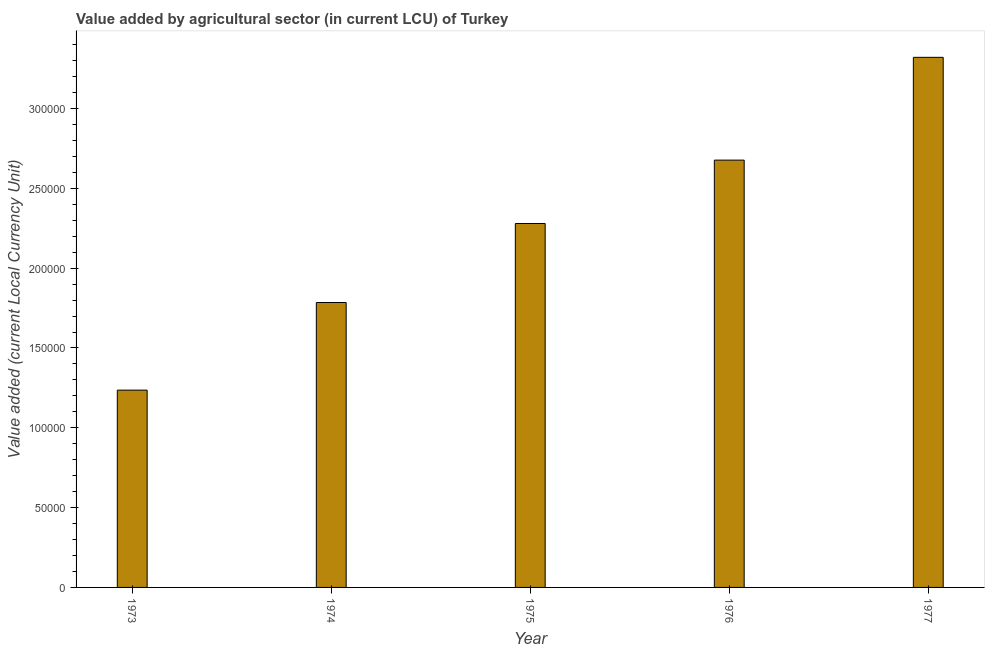Does the graph contain any zero values?
Your answer should be compact. No. What is the title of the graph?
Make the answer very short. Value added by agricultural sector (in current LCU) of Turkey. What is the label or title of the X-axis?
Your response must be concise. Year. What is the label or title of the Y-axis?
Your answer should be compact. Value added (current Local Currency Unit). What is the value added by agriculture sector in 1975?
Your answer should be compact. 2.28e+05. Across all years, what is the maximum value added by agriculture sector?
Ensure brevity in your answer.  3.32e+05. Across all years, what is the minimum value added by agriculture sector?
Make the answer very short. 1.24e+05. What is the sum of the value added by agriculture sector?
Give a very brief answer. 1.13e+06. What is the difference between the value added by agriculture sector in 1973 and 1976?
Provide a short and direct response. -1.44e+05. What is the average value added by agriculture sector per year?
Provide a short and direct response. 2.26e+05. What is the median value added by agriculture sector?
Offer a terse response. 2.28e+05. In how many years, is the value added by agriculture sector greater than 300000 LCU?
Provide a short and direct response. 1. Do a majority of the years between 1977 and 1973 (inclusive) have value added by agriculture sector greater than 150000 LCU?
Give a very brief answer. Yes. What is the ratio of the value added by agriculture sector in 1974 to that in 1975?
Provide a succinct answer. 0.78. Is the difference between the value added by agriculture sector in 1974 and 1976 greater than the difference between any two years?
Keep it short and to the point. No. What is the difference between the highest and the second highest value added by agriculture sector?
Keep it short and to the point. 6.44e+04. What is the difference between the highest and the lowest value added by agriculture sector?
Ensure brevity in your answer.  2.08e+05. How many bars are there?
Provide a succinct answer. 5. Are the values on the major ticks of Y-axis written in scientific E-notation?
Your response must be concise. No. What is the Value added (current Local Currency Unit) of 1973?
Keep it short and to the point. 1.24e+05. What is the Value added (current Local Currency Unit) in 1974?
Your answer should be compact. 1.78e+05. What is the Value added (current Local Currency Unit) of 1975?
Provide a short and direct response. 2.28e+05. What is the Value added (current Local Currency Unit) of 1976?
Your answer should be very brief. 2.68e+05. What is the Value added (current Local Currency Unit) in 1977?
Give a very brief answer. 3.32e+05. What is the difference between the Value added (current Local Currency Unit) in 1973 and 1974?
Your answer should be very brief. -5.49e+04. What is the difference between the Value added (current Local Currency Unit) in 1973 and 1975?
Make the answer very short. -1.04e+05. What is the difference between the Value added (current Local Currency Unit) in 1973 and 1976?
Offer a terse response. -1.44e+05. What is the difference between the Value added (current Local Currency Unit) in 1973 and 1977?
Offer a very short reply. -2.08e+05. What is the difference between the Value added (current Local Currency Unit) in 1974 and 1975?
Provide a succinct answer. -4.95e+04. What is the difference between the Value added (current Local Currency Unit) in 1974 and 1976?
Offer a very short reply. -8.92e+04. What is the difference between the Value added (current Local Currency Unit) in 1974 and 1977?
Offer a very short reply. -1.54e+05. What is the difference between the Value added (current Local Currency Unit) in 1975 and 1976?
Provide a short and direct response. -3.97e+04. What is the difference between the Value added (current Local Currency Unit) in 1975 and 1977?
Your response must be concise. -1.04e+05. What is the difference between the Value added (current Local Currency Unit) in 1976 and 1977?
Ensure brevity in your answer.  -6.44e+04. What is the ratio of the Value added (current Local Currency Unit) in 1973 to that in 1974?
Provide a short and direct response. 0.69. What is the ratio of the Value added (current Local Currency Unit) in 1973 to that in 1975?
Your answer should be compact. 0.54. What is the ratio of the Value added (current Local Currency Unit) in 1973 to that in 1976?
Offer a very short reply. 0.46. What is the ratio of the Value added (current Local Currency Unit) in 1973 to that in 1977?
Provide a short and direct response. 0.37. What is the ratio of the Value added (current Local Currency Unit) in 1974 to that in 1975?
Your answer should be compact. 0.78. What is the ratio of the Value added (current Local Currency Unit) in 1974 to that in 1976?
Keep it short and to the point. 0.67. What is the ratio of the Value added (current Local Currency Unit) in 1974 to that in 1977?
Provide a succinct answer. 0.54. What is the ratio of the Value added (current Local Currency Unit) in 1975 to that in 1976?
Make the answer very short. 0.85. What is the ratio of the Value added (current Local Currency Unit) in 1975 to that in 1977?
Give a very brief answer. 0.69. What is the ratio of the Value added (current Local Currency Unit) in 1976 to that in 1977?
Your answer should be compact. 0.81. 